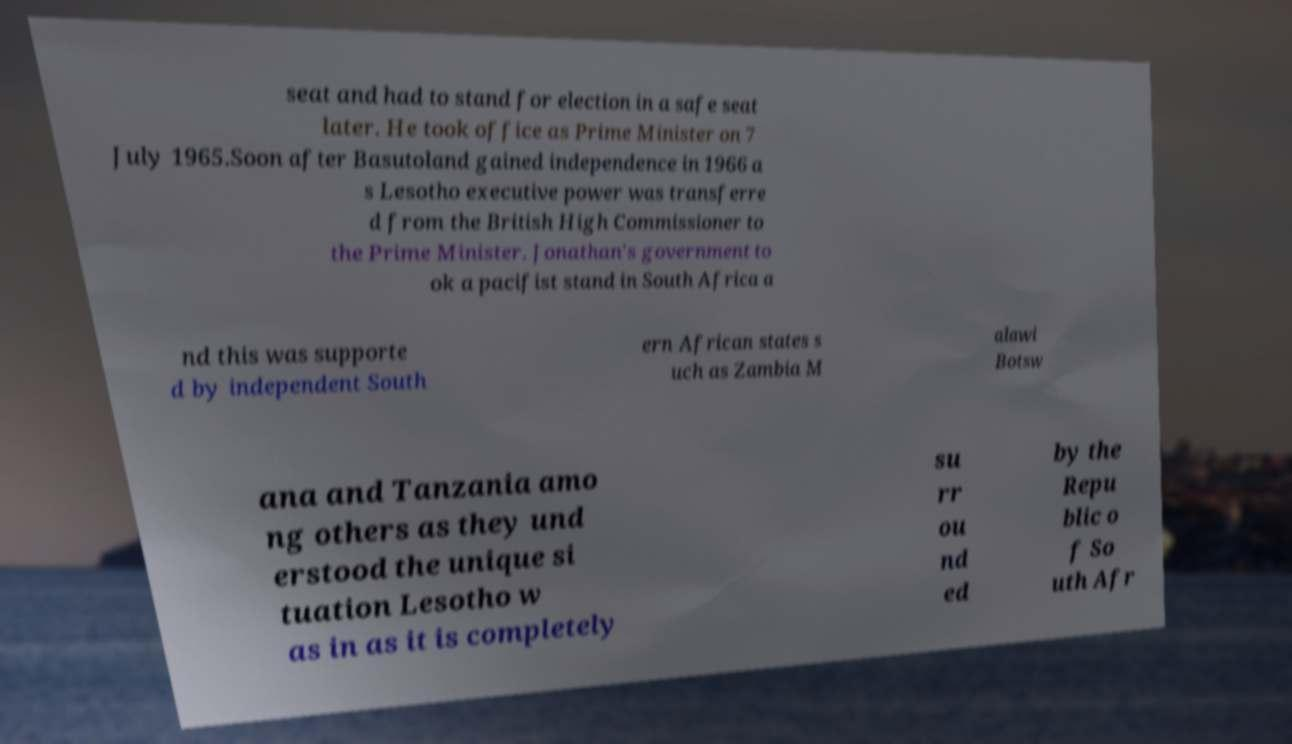There's text embedded in this image that I need extracted. Can you transcribe it verbatim? seat and had to stand for election in a safe seat later. He took office as Prime Minister on 7 July 1965.Soon after Basutoland gained independence in 1966 a s Lesotho executive power was transferre d from the British High Commissioner to the Prime Minister. Jonathan's government to ok a pacifist stand in South Africa a nd this was supporte d by independent South ern African states s uch as Zambia M alawi Botsw ana and Tanzania amo ng others as they und erstood the unique si tuation Lesotho w as in as it is completely su rr ou nd ed by the Repu blic o f So uth Afr 